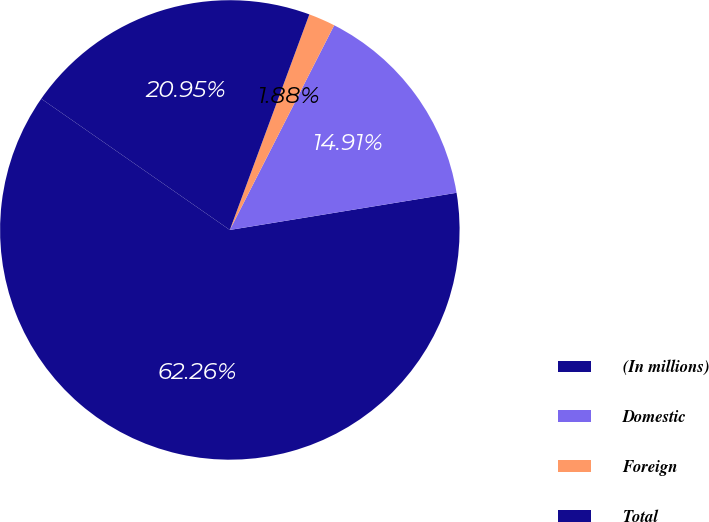Convert chart to OTSL. <chart><loc_0><loc_0><loc_500><loc_500><pie_chart><fcel>(In millions)<fcel>Domestic<fcel>Foreign<fcel>Total<nl><fcel>62.26%<fcel>14.91%<fcel>1.88%<fcel>20.95%<nl></chart> 